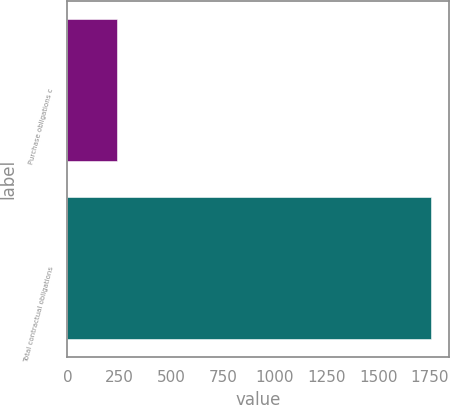Convert chart. <chart><loc_0><loc_0><loc_500><loc_500><bar_chart><fcel>Purchase obligations c<fcel>Total contractual obligations<nl><fcel>239<fcel>1753<nl></chart> 